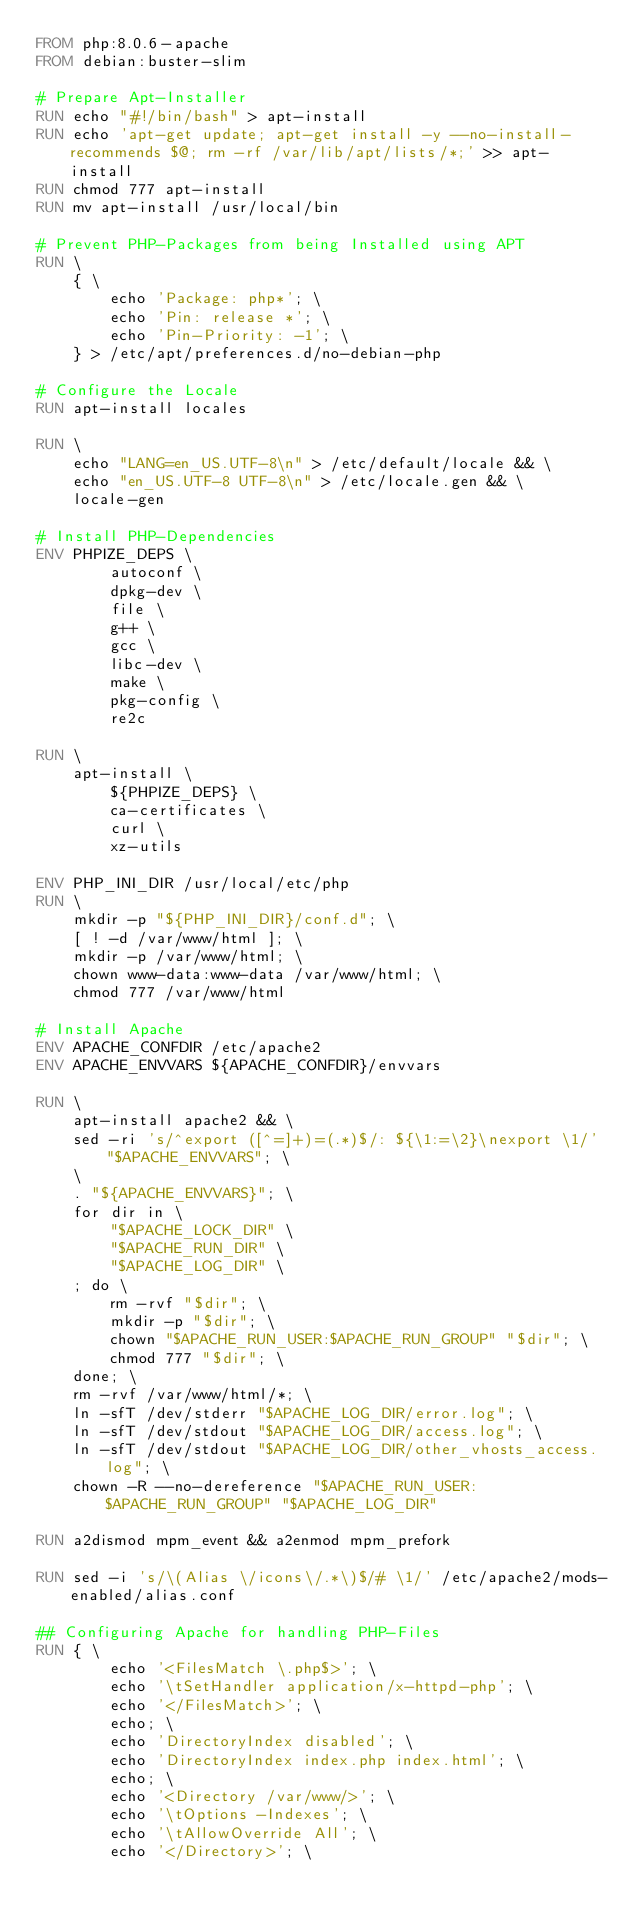Convert code to text. <code><loc_0><loc_0><loc_500><loc_500><_Dockerfile_>FROM php:8.0.6-apache
FROM debian:buster-slim

# Prepare Apt-Installer
RUN echo "#!/bin/bash" > apt-install
RUN echo 'apt-get update; apt-get install -y --no-install-recommends $@; rm -rf /var/lib/apt/lists/*;' >> apt-install
RUN chmod 777 apt-install
RUN mv apt-install /usr/local/bin

# Prevent PHP-Packages from being Installed using APT
RUN \
    { \
        echo 'Package: php*'; \
        echo 'Pin: release *'; \
        echo 'Pin-Priority: -1'; \
    } > /etc/apt/preferences.d/no-debian-php

# Configure the Locale
RUN apt-install locales

RUN \
    echo "LANG=en_US.UTF-8\n" > /etc/default/locale && \
    echo "en_US.UTF-8 UTF-8\n" > /etc/locale.gen && \
    locale-gen

# Install PHP-Dependencies
ENV PHPIZE_DEPS \
        autoconf \
        dpkg-dev \
        file \
        g++ \
        gcc \
        libc-dev \
        make \
        pkg-config \
        re2c

RUN \
    apt-install \
        ${PHPIZE_DEPS} \
        ca-certificates \
        curl \
        xz-utils

ENV PHP_INI_DIR /usr/local/etc/php
RUN \
    mkdir -p "${PHP_INI_DIR}/conf.d"; \
    [ ! -d /var/www/html ]; \
    mkdir -p /var/www/html; \
    chown www-data:www-data /var/www/html; \
    chmod 777 /var/www/html

# Install Apache
ENV APACHE_CONFDIR /etc/apache2
ENV APACHE_ENVVARS ${APACHE_CONFDIR}/envvars

RUN \
    apt-install apache2 && \
    sed -ri 's/^export ([^=]+)=(.*)$/: ${\1:=\2}\nexport \1/' "$APACHE_ENVVARS"; \
    \
    . "${APACHE_ENVVARS}"; \
    for dir in \
        "$APACHE_LOCK_DIR" \
        "$APACHE_RUN_DIR" \
        "$APACHE_LOG_DIR" \
    ; do \
        rm -rvf "$dir"; \
        mkdir -p "$dir"; \
        chown "$APACHE_RUN_USER:$APACHE_RUN_GROUP" "$dir"; \
        chmod 777 "$dir"; \
    done; \
    rm -rvf /var/www/html/*; \
    ln -sfT /dev/stderr "$APACHE_LOG_DIR/error.log"; \
    ln -sfT /dev/stdout "$APACHE_LOG_DIR/access.log"; \
    ln -sfT /dev/stdout "$APACHE_LOG_DIR/other_vhosts_access.log"; \
    chown -R --no-dereference "$APACHE_RUN_USER:$APACHE_RUN_GROUP" "$APACHE_LOG_DIR"

RUN a2dismod mpm_event && a2enmod mpm_prefork

RUN sed -i 's/\(Alias \/icons\/.*\)$/# \1/' /etc/apache2/mods-enabled/alias.conf

## Configuring Apache for handling PHP-Files
RUN { \
        echo '<FilesMatch \.php$>'; \
        echo '\tSetHandler application/x-httpd-php'; \
        echo '</FilesMatch>'; \
        echo; \
        echo 'DirectoryIndex disabled'; \
        echo 'DirectoryIndex index.php index.html'; \
        echo; \
        echo '<Directory /var/www/>'; \
        echo '\tOptions -Indexes'; \
        echo '\tAllowOverride All'; \
        echo '</Directory>'; \</code> 